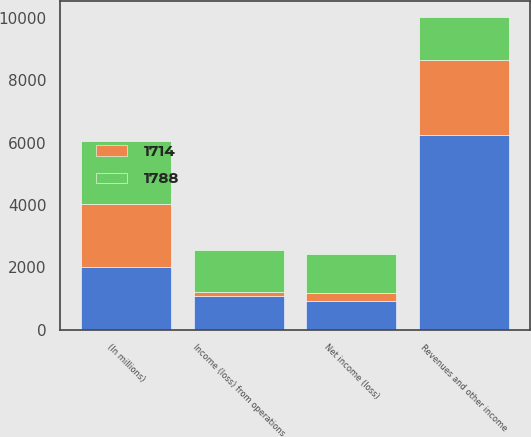Convert chart. <chart><loc_0><loc_0><loc_500><loc_500><stacked_bar_chart><ecel><fcel>(In millions)<fcel>Revenues and other income<fcel>Income (loss) from operations<fcel>Net income (loss)<nl><fcel>1788<fcel>2018<fcel>1375<fcel>1375<fcel>1242<nl><fcel>nan<fcel>2017<fcel>6235<fcel>1075<fcel>922<nl><fcel>1714<fcel>2016<fcel>2421<fcel>116<fcel>250<nl></chart> 